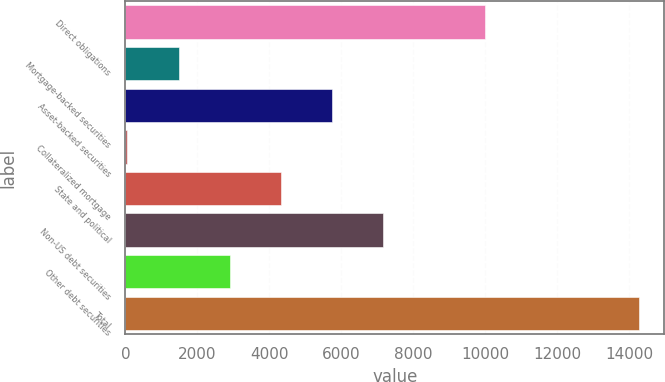Convert chart to OTSL. <chart><loc_0><loc_0><loc_500><loc_500><bar_chart><fcel>Direct obligations<fcel>Mortgage-backed securities<fcel>Asset-backed securities<fcel>Collateralized mortgage<fcel>State and political<fcel>Non-US debt securities<fcel>Other debt securities<fcel>Total<nl><fcel>10001<fcel>1479.5<fcel>5744<fcel>58<fcel>4322.5<fcel>7165.5<fcel>2901<fcel>14273<nl></chart> 